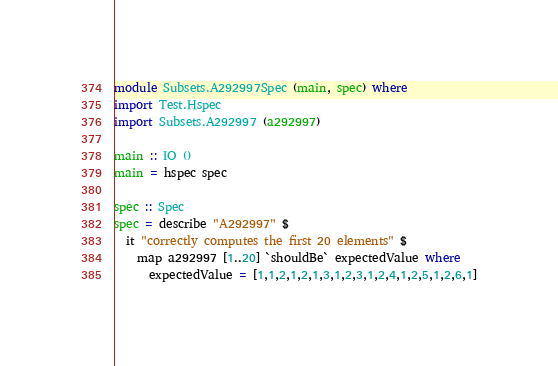<code> <loc_0><loc_0><loc_500><loc_500><_Haskell_>module Subsets.A292997Spec (main, spec) where
import Test.Hspec
import Subsets.A292997 (a292997)

main :: IO ()
main = hspec spec

spec :: Spec
spec = describe "A292997" $
  it "correctly computes the first 20 elements" $
    map a292997 [1..20] `shouldBe` expectedValue where
      expectedValue = [1,1,2,1,2,1,3,1,2,3,1,2,4,1,2,5,1,2,6,1]
</code> 